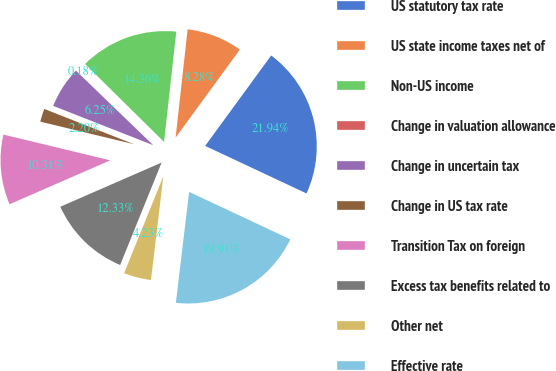Convert chart. <chart><loc_0><loc_0><loc_500><loc_500><pie_chart><fcel>US statutory tax rate<fcel>US state income taxes net of<fcel>Non-US income<fcel>Change in valuation allowance<fcel>Change in uncertain tax<fcel>Change in US tax rate<fcel>Transition Tax on foreign<fcel>Excess tax benefits related to<fcel>Other net<fcel>Effective rate<nl><fcel>21.94%<fcel>8.28%<fcel>14.36%<fcel>0.18%<fcel>6.25%<fcel>2.2%<fcel>10.31%<fcel>12.33%<fcel>4.23%<fcel>19.91%<nl></chart> 